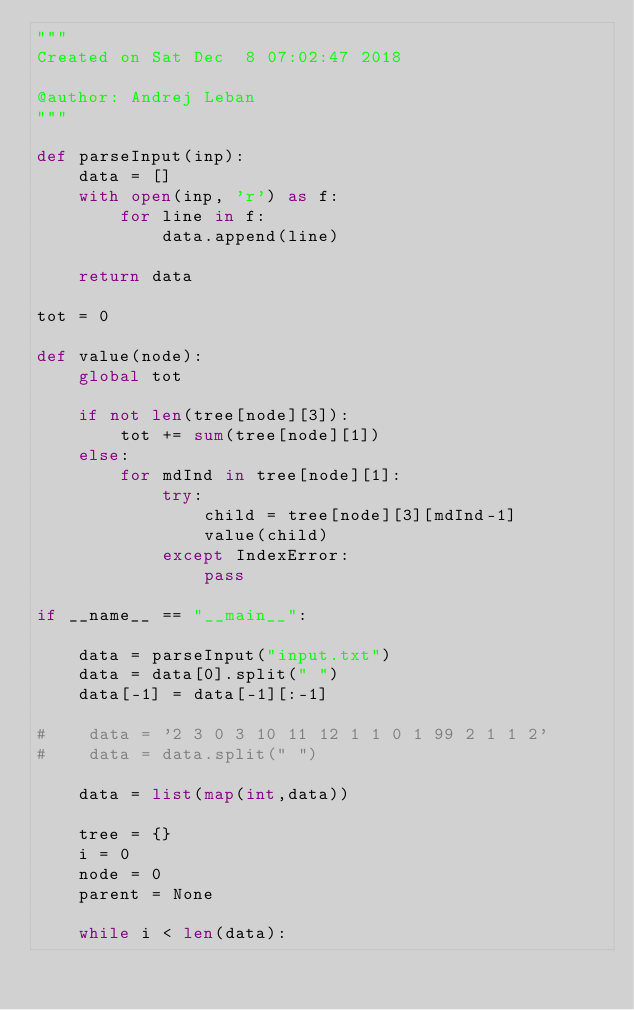<code> <loc_0><loc_0><loc_500><loc_500><_Python_>"""
Created on Sat Dec  8 07:02:47 2018

@author: Andrej Leban
"""

def parseInput(inp):
    data = []
    with open(inp, 'r') as f:
        for line in f:
            data.append(line)

    return data

tot = 0

def value(node):
    global tot

    if not len(tree[node][3]):
        tot += sum(tree[node][1])
    else:
        for mdInd in tree[node][1]:
            try:
                child = tree[node][3][mdInd-1]
                value(child)
            except IndexError:
                pass

if __name__ == "__main__":

    data = parseInput("input.txt")
    data = data[0].split(" ")
    data[-1] = data[-1][:-1]

#    data = '2 3 0 3 10 11 12 1 1 0 1 99 2 1 1 2'
#    data = data.split(" ")

    data = list(map(int,data))

    tree = {}
    i = 0
    node = 0
    parent = None

    while i < len(data):
</code> 